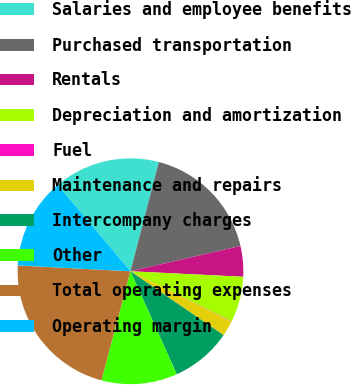Convert chart. <chart><loc_0><loc_0><loc_500><loc_500><pie_chart><fcel>Salaries and employee benefits<fcel>Purchased transportation<fcel>Rentals<fcel>Depreciation and amortization<fcel>Fuel<fcel>Maintenance and repairs<fcel>Intercompany charges<fcel>Other<fcel>Total operating expenses<fcel>Operating margin<nl><fcel>15.19%<fcel>17.35%<fcel>4.38%<fcel>6.54%<fcel>0.05%<fcel>2.21%<fcel>8.7%<fcel>10.87%<fcel>21.68%<fcel>13.03%<nl></chart> 